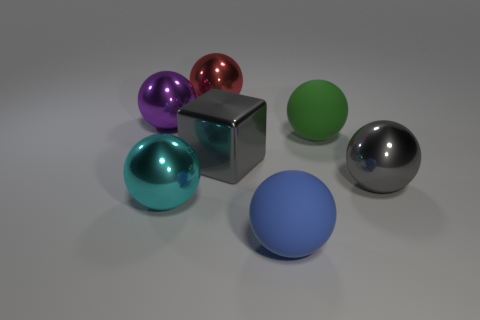What is the color of the shiny cube that is the same size as the red thing?
Provide a short and direct response. Gray. Is the size of the metallic ball on the right side of the red ball the same as the metal sphere left of the big cyan object?
Your response must be concise. Yes. There is a matte thing that is in front of the big rubber thing behind the large metal sphere on the right side of the big blue sphere; what is its size?
Provide a short and direct response. Large. The cyan shiny object to the right of the big metallic object to the left of the big cyan shiny sphere is what shape?
Offer a very short reply. Sphere. Does the large rubber thing that is in front of the large cyan object have the same color as the shiny block?
Provide a succinct answer. No. There is a sphere that is in front of the big gray metallic ball and behind the big blue object; what is its color?
Provide a succinct answer. Cyan. Is there a big blue object made of the same material as the blue sphere?
Your response must be concise. No. What is the size of the blue thing?
Keep it short and to the point. Large. How big is the metal sphere that is to the right of the big metal sphere that is behind the large purple thing?
Ensure brevity in your answer.  Large. There is a red object that is the same shape as the big cyan object; what is it made of?
Provide a succinct answer. Metal. 